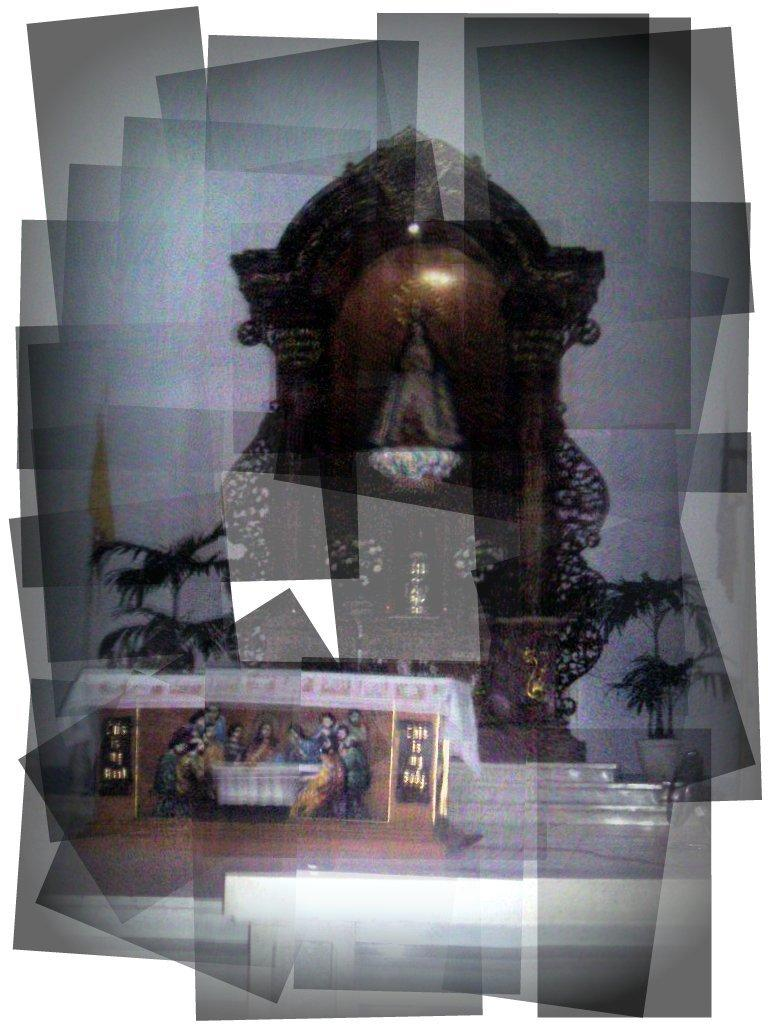What is the main subject in the image? There is a statue in the image. Are there any other objects or items in the image? Yes, there is a photo in the image. Can you describe any other visual elements in the image? The image contains a reflection of some objects. How many passengers are visible in the image? There are no passengers present in the image; it features a statue and a photo. What type of stitch is used to create the statue in the image? The image does not provide information about the type of stitch used to create the statue, as it is likely a solid structure rather than a fabric or textile. 